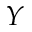<formula> <loc_0><loc_0><loc_500><loc_500>Y</formula> 